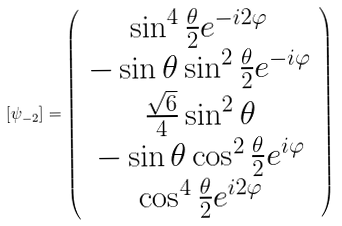<formula> <loc_0><loc_0><loc_500><loc_500>[ \psi _ { - 2 } ] = \left ( \begin{array} { c } \sin ^ { 4 } \frac { \theta } { 2 } e ^ { - i 2 \varphi } \\ - \sin \theta \sin ^ { 2 } \frac { \theta } { 2 } e ^ { - i \varphi } \\ \frac { \sqrt { 6 } } 4 \sin ^ { 2 } \theta \\ - \sin \theta \cos ^ { 2 } \frac { \theta } { 2 } e ^ { i \varphi } \\ \cos ^ { 4 } \frac { \theta } { 2 } e ^ { i 2 \varphi } \end{array} \right )</formula> 